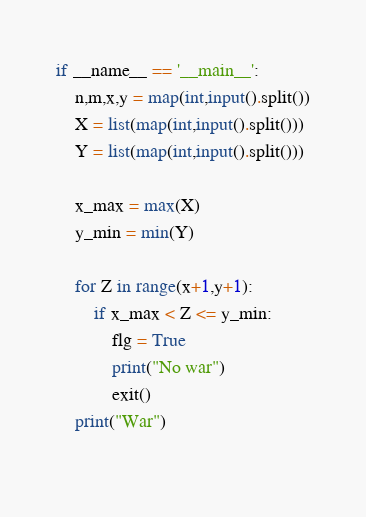<code> <loc_0><loc_0><loc_500><loc_500><_Python_>if __name__ == '__main__':
	n,m,x,y = map(int,input().split())
	X = list(map(int,input().split()))
	Y = list(map(int,input().split()))
 
	x_max = max(X)
	y_min = min(Y)

	for Z in range(x+1,y+1):
		if x_max < Z <= y_min:
			flg = True
			print("No war")
			exit()
	print("War")
 </code> 